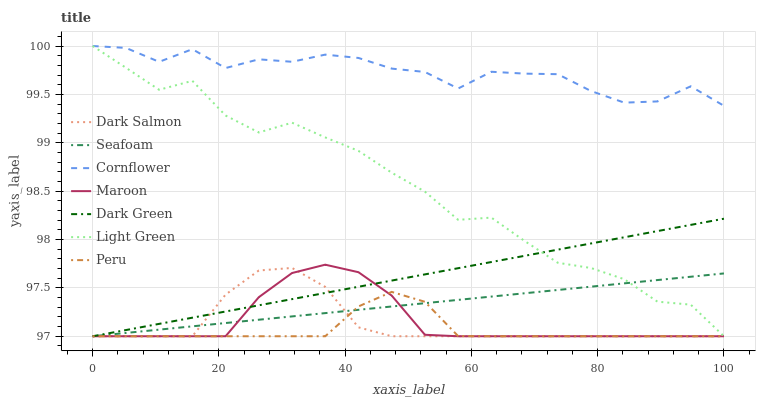Does Peru have the minimum area under the curve?
Answer yes or no. Yes. Does Cornflower have the maximum area under the curve?
Answer yes or no. Yes. Does Dark Salmon have the minimum area under the curve?
Answer yes or no. No. Does Dark Salmon have the maximum area under the curve?
Answer yes or no. No. Is Dark Green the smoothest?
Answer yes or no. Yes. Is Light Green the roughest?
Answer yes or no. Yes. Is Peru the smoothest?
Answer yes or no. No. Is Peru the roughest?
Answer yes or no. No. Does Peru have the lowest value?
Answer yes or no. Yes. Does Light Green have the highest value?
Answer yes or no. Yes. Does Dark Salmon have the highest value?
Answer yes or no. No. Is Seafoam less than Cornflower?
Answer yes or no. Yes. Is Cornflower greater than Dark Salmon?
Answer yes or no. Yes. Does Dark Green intersect Light Green?
Answer yes or no. Yes. Is Dark Green less than Light Green?
Answer yes or no. No. Is Dark Green greater than Light Green?
Answer yes or no. No. Does Seafoam intersect Cornflower?
Answer yes or no. No. 